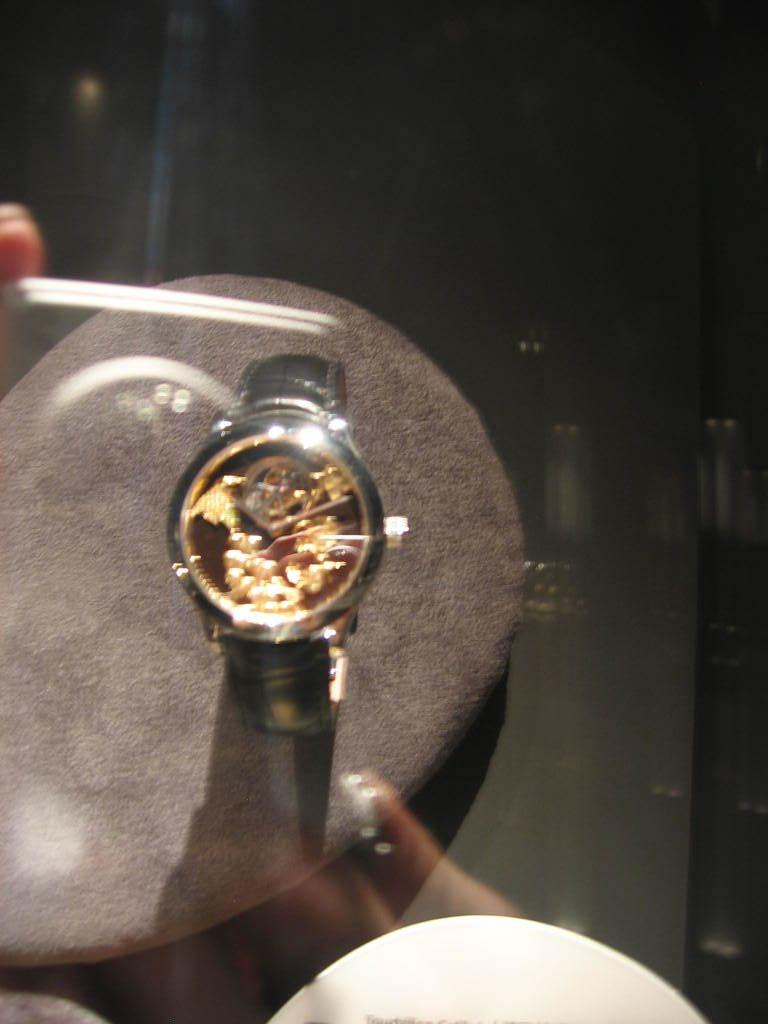What object is placed on a stand in the image? There is a watch on a stand in the image. Can you describe the watch's position in the image? The watch is placed on a stand in the image. What type of amusement can be seen in the image? There is no amusement present in the image; it features a watch on a stand. How many cakes are visible on the stand with the watch? There are no cakes present in the image; it features a watch on a stand. What kind of fish is swimming in the image? There is no fish present in the image; it features a watch on a stand. 